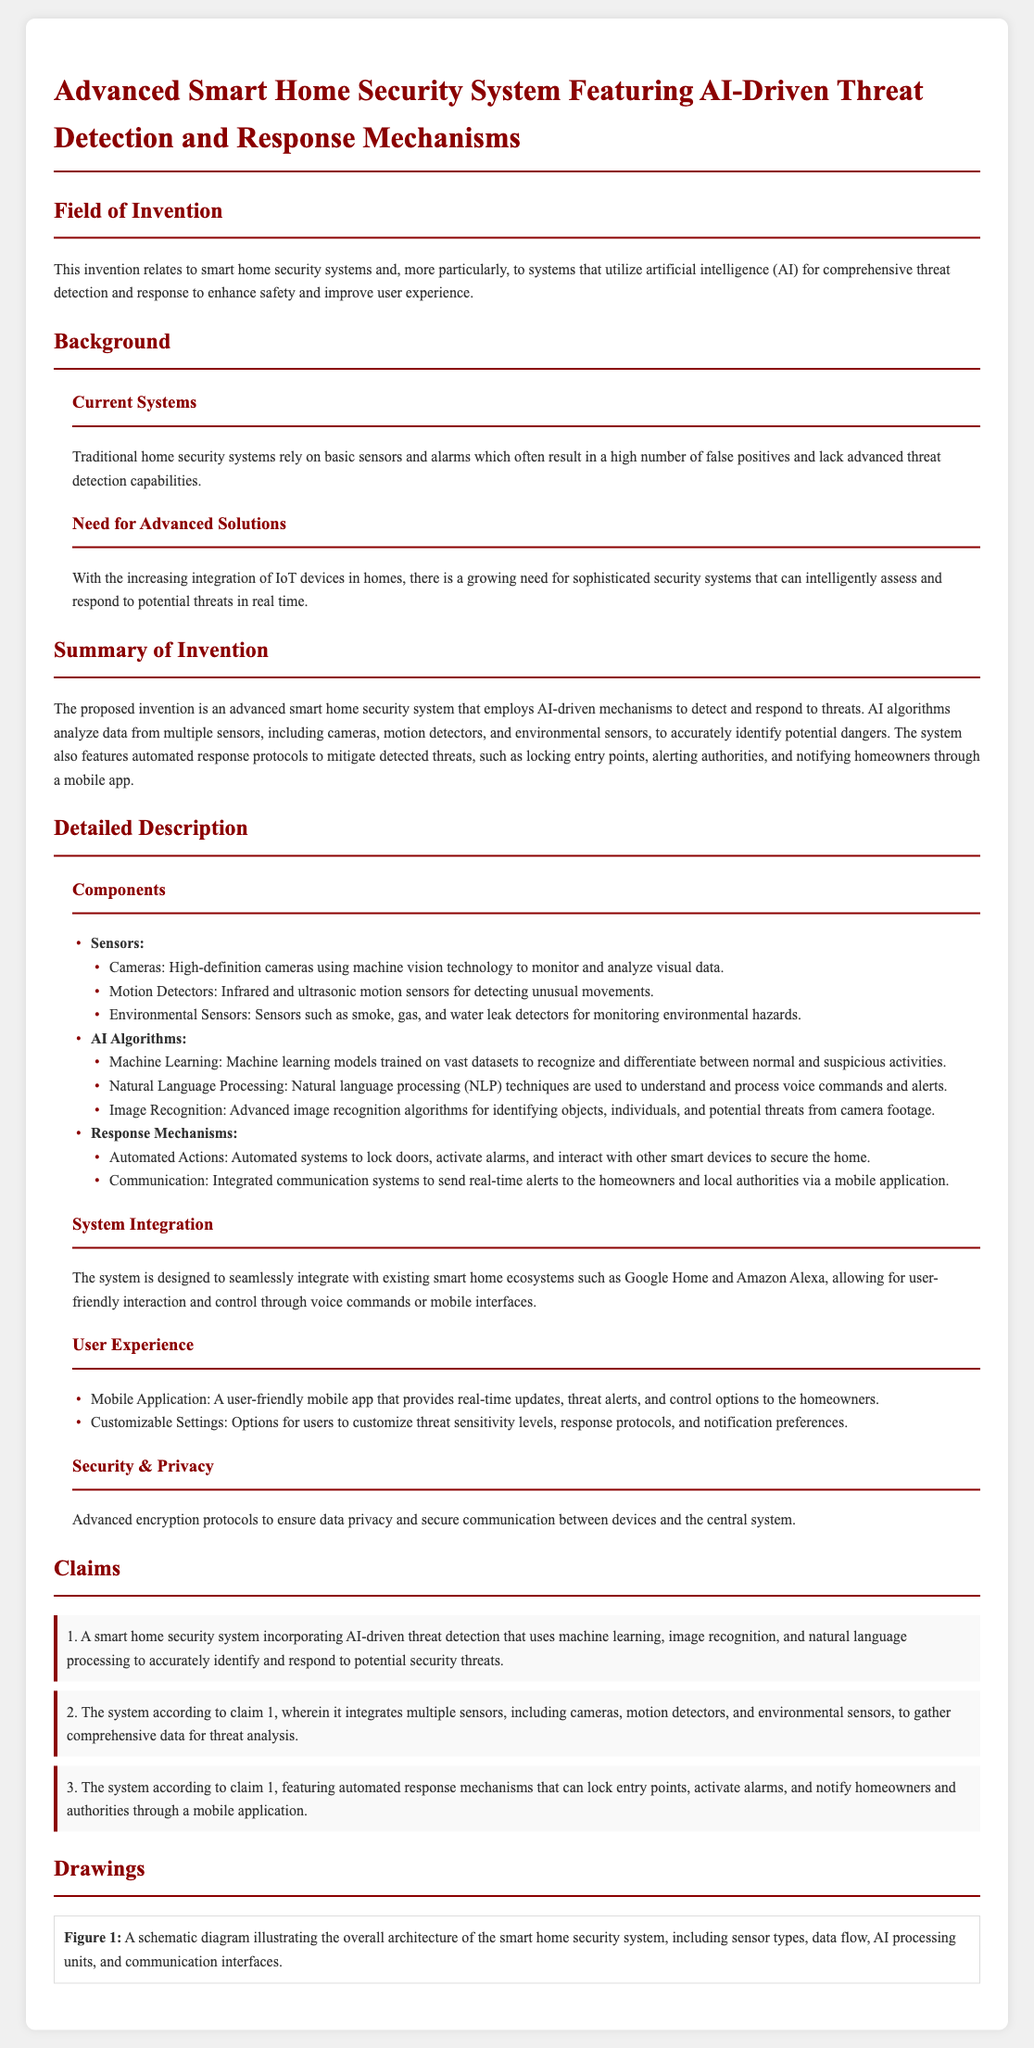What is the field of invention? The field of invention described in the document relates to smart home security systems that utilize artificial intelligence for comprehensive threat detection and response.
Answer: Smart home security systems What sensors are included in the system? The system incorporates multiple sensors: cameras, motion detectors, and environmental sensors for comprehensive threat analysis.
Answer: Cameras, motion detectors, environmental sensors What technology is used for image recognition? The advanced image recognition algorithms mentioned in the document are utilized for identifying objects, individuals, and potential threats.
Answer: Advanced image recognition algorithms What is the purpose of the AI algorithms? The AI algorithms analyze data from multiple sensors to accurately identify potential dangers in the smart home security system.
Answer: Accurately identify potential dangers Which mobile platforms does the system integrate with? The system integrates with existing smart home ecosystems such as Google Home and Amazon Alexa for user-friendly interaction.
Answer: Google Home and Amazon Alexa What is one automated action the system can perform? The system features automated actions such as locking doors, activating alarms, and interacting with other smart devices to secure the home.
Answer: Locking doors How many claims are made in the document? There are a total of three claims outlined in the claims section of the patent application.
Answer: Three Claims What is the primary functionality of the proposed security system? The proposed invention primarily functions as an advanced smart home security system employing AI-driven mechanisms for threat detection and response.
Answer: Threat detection and response What types of notifications are sent to homeowners? The system notifies homeowners through a mobile application via real-time alerts about detected threats.
Answer: Real-time alerts through a mobile application 